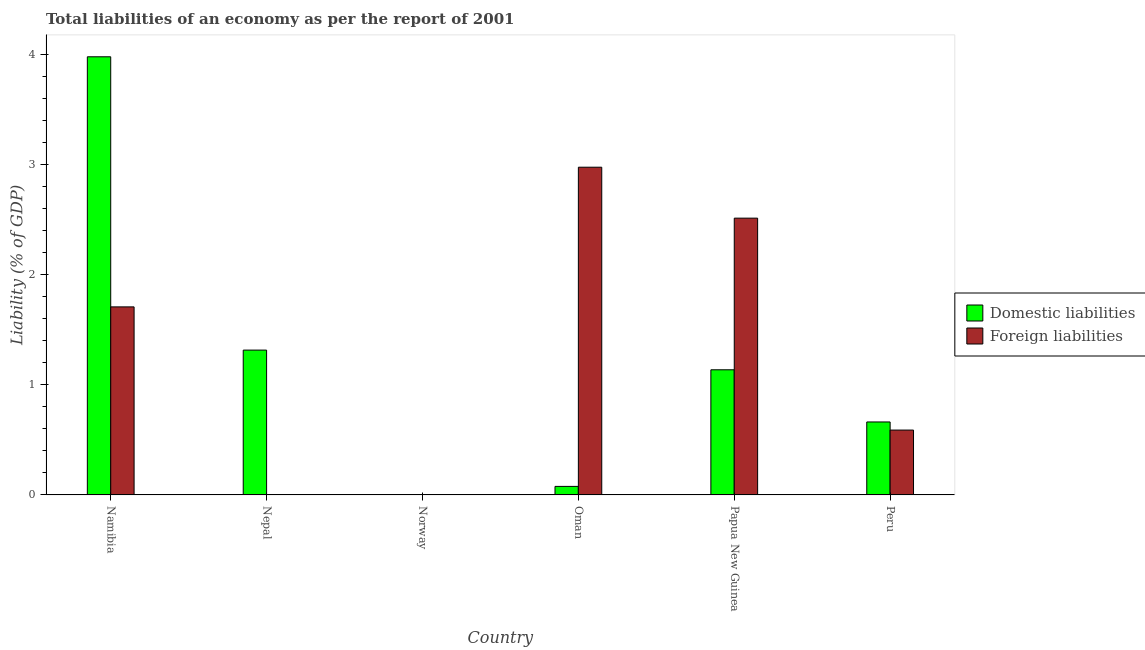Are the number of bars per tick equal to the number of legend labels?
Offer a terse response. No. Are the number of bars on each tick of the X-axis equal?
Make the answer very short. No. How many bars are there on the 2nd tick from the left?
Ensure brevity in your answer.  1. In how many cases, is the number of bars for a given country not equal to the number of legend labels?
Offer a very short reply. 2. What is the incurrence of domestic liabilities in Papua New Guinea?
Keep it short and to the point. 1.14. Across all countries, what is the maximum incurrence of domestic liabilities?
Provide a succinct answer. 3.98. In which country was the incurrence of domestic liabilities maximum?
Offer a terse response. Namibia. What is the total incurrence of foreign liabilities in the graph?
Give a very brief answer. 7.79. What is the difference between the incurrence of domestic liabilities in Namibia and that in Oman?
Offer a very short reply. 3.9. What is the difference between the incurrence of foreign liabilities in Norway and the incurrence of domestic liabilities in Peru?
Your answer should be very brief. -0.66. What is the average incurrence of foreign liabilities per country?
Provide a succinct answer. 1.3. What is the difference between the incurrence of foreign liabilities and incurrence of domestic liabilities in Namibia?
Offer a terse response. -2.27. What is the ratio of the incurrence of foreign liabilities in Papua New Guinea to that in Peru?
Offer a very short reply. 4.27. Is the incurrence of domestic liabilities in Namibia less than that in Nepal?
Your answer should be compact. No. What is the difference between the highest and the second highest incurrence of foreign liabilities?
Your response must be concise. 0.46. What is the difference between the highest and the lowest incurrence of domestic liabilities?
Provide a short and direct response. 3.98. In how many countries, is the incurrence of domestic liabilities greater than the average incurrence of domestic liabilities taken over all countries?
Make the answer very short. 2. Is the sum of the incurrence of foreign liabilities in Namibia and Peru greater than the maximum incurrence of domestic liabilities across all countries?
Provide a succinct answer. No. How many bars are there?
Offer a very short reply. 9. How many countries are there in the graph?
Make the answer very short. 6. Does the graph contain any zero values?
Offer a very short reply. Yes. Does the graph contain grids?
Your answer should be very brief. No. Where does the legend appear in the graph?
Provide a succinct answer. Center right. What is the title of the graph?
Provide a short and direct response. Total liabilities of an economy as per the report of 2001. What is the label or title of the Y-axis?
Offer a terse response. Liability (% of GDP). What is the Liability (% of GDP) in Domestic liabilities in Namibia?
Provide a short and direct response. 3.98. What is the Liability (% of GDP) of Foreign liabilities in Namibia?
Your response must be concise. 1.71. What is the Liability (% of GDP) of Domestic liabilities in Nepal?
Offer a very short reply. 1.32. What is the Liability (% of GDP) in Foreign liabilities in Norway?
Keep it short and to the point. 0. What is the Liability (% of GDP) in Domestic liabilities in Oman?
Make the answer very short. 0.08. What is the Liability (% of GDP) of Foreign liabilities in Oman?
Ensure brevity in your answer.  2.98. What is the Liability (% of GDP) of Domestic liabilities in Papua New Guinea?
Provide a succinct answer. 1.14. What is the Liability (% of GDP) of Foreign liabilities in Papua New Guinea?
Keep it short and to the point. 2.51. What is the Liability (% of GDP) in Domestic liabilities in Peru?
Ensure brevity in your answer.  0.66. What is the Liability (% of GDP) of Foreign liabilities in Peru?
Your response must be concise. 0.59. Across all countries, what is the maximum Liability (% of GDP) of Domestic liabilities?
Ensure brevity in your answer.  3.98. Across all countries, what is the maximum Liability (% of GDP) in Foreign liabilities?
Provide a succinct answer. 2.98. Across all countries, what is the minimum Liability (% of GDP) of Domestic liabilities?
Provide a short and direct response. 0. Across all countries, what is the minimum Liability (% of GDP) of Foreign liabilities?
Offer a very short reply. 0. What is the total Liability (% of GDP) of Domestic liabilities in the graph?
Give a very brief answer. 7.17. What is the total Liability (% of GDP) of Foreign liabilities in the graph?
Offer a terse response. 7.79. What is the difference between the Liability (% of GDP) in Domestic liabilities in Namibia and that in Nepal?
Provide a short and direct response. 2.67. What is the difference between the Liability (% of GDP) of Domestic liabilities in Namibia and that in Oman?
Provide a short and direct response. 3.9. What is the difference between the Liability (% of GDP) in Foreign liabilities in Namibia and that in Oman?
Provide a succinct answer. -1.27. What is the difference between the Liability (% of GDP) of Domestic liabilities in Namibia and that in Papua New Guinea?
Keep it short and to the point. 2.84. What is the difference between the Liability (% of GDP) of Foreign liabilities in Namibia and that in Papua New Guinea?
Your response must be concise. -0.81. What is the difference between the Liability (% of GDP) of Domestic liabilities in Namibia and that in Peru?
Your answer should be very brief. 3.32. What is the difference between the Liability (% of GDP) in Foreign liabilities in Namibia and that in Peru?
Ensure brevity in your answer.  1.12. What is the difference between the Liability (% of GDP) in Domestic liabilities in Nepal and that in Oman?
Provide a short and direct response. 1.24. What is the difference between the Liability (% of GDP) of Domestic liabilities in Nepal and that in Papua New Guinea?
Provide a short and direct response. 0.18. What is the difference between the Liability (% of GDP) in Domestic liabilities in Nepal and that in Peru?
Offer a terse response. 0.65. What is the difference between the Liability (% of GDP) of Domestic liabilities in Oman and that in Papua New Guinea?
Ensure brevity in your answer.  -1.06. What is the difference between the Liability (% of GDP) in Foreign liabilities in Oman and that in Papua New Guinea?
Keep it short and to the point. 0.46. What is the difference between the Liability (% of GDP) in Domestic liabilities in Oman and that in Peru?
Provide a short and direct response. -0.59. What is the difference between the Liability (% of GDP) of Foreign liabilities in Oman and that in Peru?
Offer a terse response. 2.39. What is the difference between the Liability (% of GDP) in Domestic liabilities in Papua New Guinea and that in Peru?
Provide a succinct answer. 0.47. What is the difference between the Liability (% of GDP) in Foreign liabilities in Papua New Guinea and that in Peru?
Keep it short and to the point. 1.93. What is the difference between the Liability (% of GDP) in Domestic liabilities in Namibia and the Liability (% of GDP) in Foreign liabilities in Oman?
Provide a short and direct response. 1. What is the difference between the Liability (% of GDP) in Domestic liabilities in Namibia and the Liability (% of GDP) in Foreign liabilities in Papua New Guinea?
Provide a succinct answer. 1.47. What is the difference between the Liability (% of GDP) in Domestic liabilities in Namibia and the Liability (% of GDP) in Foreign liabilities in Peru?
Make the answer very short. 3.39. What is the difference between the Liability (% of GDP) of Domestic liabilities in Nepal and the Liability (% of GDP) of Foreign liabilities in Oman?
Your answer should be very brief. -1.66. What is the difference between the Liability (% of GDP) in Domestic liabilities in Nepal and the Liability (% of GDP) in Foreign liabilities in Papua New Guinea?
Ensure brevity in your answer.  -1.2. What is the difference between the Liability (% of GDP) in Domestic liabilities in Nepal and the Liability (% of GDP) in Foreign liabilities in Peru?
Offer a terse response. 0.73. What is the difference between the Liability (% of GDP) of Domestic liabilities in Oman and the Liability (% of GDP) of Foreign liabilities in Papua New Guinea?
Provide a short and direct response. -2.44. What is the difference between the Liability (% of GDP) in Domestic liabilities in Oman and the Liability (% of GDP) in Foreign liabilities in Peru?
Offer a terse response. -0.51. What is the difference between the Liability (% of GDP) of Domestic liabilities in Papua New Guinea and the Liability (% of GDP) of Foreign liabilities in Peru?
Keep it short and to the point. 0.55. What is the average Liability (% of GDP) of Domestic liabilities per country?
Your response must be concise. 1.2. What is the average Liability (% of GDP) of Foreign liabilities per country?
Keep it short and to the point. 1.3. What is the difference between the Liability (% of GDP) in Domestic liabilities and Liability (% of GDP) in Foreign liabilities in Namibia?
Offer a terse response. 2.27. What is the difference between the Liability (% of GDP) in Domestic liabilities and Liability (% of GDP) in Foreign liabilities in Oman?
Provide a short and direct response. -2.9. What is the difference between the Liability (% of GDP) in Domestic liabilities and Liability (% of GDP) in Foreign liabilities in Papua New Guinea?
Provide a succinct answer. -1.38. What is the difference between the Liability (% of GDP) in Domestic liabilities and Liability (% of GDP) in Foreign liabilities in Peru?
Your answer should be very brief. 0.07. What is the ratio of the Liability (% of GDP) in Domestic liabilities in Namibia to that in Nepal?
Keep it short and to the point. 3.03. What is the ratio of the Liability (% of GDP) in Domestic liabilities in Namibia to that in Oman?
Your answer should be very brief. 51.34. What is the ratio of the Liability (% of GDP) of Foreign liabilities in Namibia to that in Oman?
Your response must be concise. 0.57. What is the ratio of the Liability (% of GDP) of Domestic liabilities in Namibia to that in Papua New Guinea?
Offer a very short reply. 3.5. What is the ratio of the Liability (% of GDP) of Foreign liabilities in Namibia to that in Papua New Guinea?
Your answer should be very brief. 0.68. What is the ratio of the Liability (% of GDP) in Domestic liabilities in Namibia to that in Peru?
Your response must be concise. 6. What is the ratio of the Liability (% of GDP) in Foreign liabilities in Namibia to that in Peru?
Provide a short and direct response. 2.9. What is the ratio of the Liability (% of GDP) in Domestic liabilities in Nepal to that in Oman?
Make the answer very short. 16.97. What is the ratio of the Liability (% of GDP) in Domestic liabilities in Nepal to that in Papua New Guinea?
Offer a terse response. 1.16. What is the ratio of the Liability (% of GDP) of Domestic liabilities in Nepal to that in Peru?
Your answer should be very brief. 1.98. What is the ratio of the Liability (% of GDP) of Domestic liabilities in Oman to that in Papua New Guinea?
Give a very brief answer. 0.07. What is the ratio of the Liability (% of GDP) of Foreign liabilities in Oman to that in Papua New Guinea?
Make the answer very short. 1.18. What is the ratio of the Liability (% of GDP) of Domestic liabilities in Oman to that in Peru?
Your answer should be compact. 0.12. What is the ratio of the Liability (% of GDP) of Foreign liabilities in Oman to that in Peru?
Provide a short and direct response. 5.05. What is the ratio of the Liability (% of GDP) of Domestic liabilities in Papua New Guinea to that in Peru?
Give a very brief answer. 1.71. What is the ratio of the Liability (% of GDP) of Foreign liabilities in Papua New Guinea to that in Peru?
Keep it short and to the point. 4.27. What is the difference between the highest and the second highest Liability (% of GDP) in Domestic liabilities?
Provide a succinct answer. 2.67. What is the difference between the highest and the second highest Liability (% of GDP) in Foreign liabilities?
Your response must be concise. 0.46. What is the difference between the highest and the lowest Liability (% of GDP) in Domestic liabilities?
Offer a terse response. 3.98. What is the difference between the highest and the lowest Liability (% of GDP) of Foreign liabilities?
Keep it short and to the point. 2.98. 